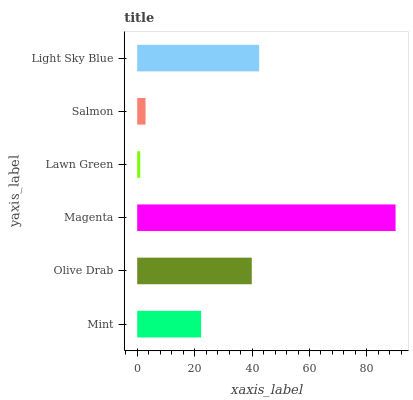Is Lawn Green the minimum?
Answer yes or no. Yes. Is Magenta the maximum?
Answer yes or no. Yes. Is Olive Drab the minimum?
Answer yes or no. No. Is Olive Drab the maximum?
Answer yes or no. No. Is Olive Drab greater than Mint?
Answer yes or no. Yes. Is Mint less than Olive Drab?
Answer yes or no. Yes. Is Mint greater than Olive Drab?
Answer yes or no. No. Is Olive Drab less than Mint?
Answer yes or no. No. Is Olive Drab the high median?
Answer yes or no. Yes. Is Mint the low median?
Answer yes or no. Yes. Is Salmon the high median?
Answer yes or no. No. Is Salmon the low median?
Answer yes or no. No. 